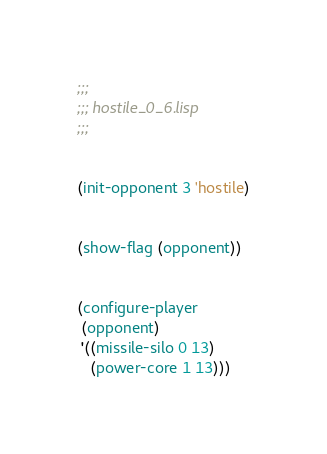<code> <loc_0><loc_0><loc_500><loc_500><_Lisp_>;;;
;;; hostile_0_6.lisp
;;;


(init-opponent 3 'hostile)


(show-flag (opponent))


(configure-player
 (opponent)
 '((missile-silo 0 13)
   (power-core 1 13)))
</code> 